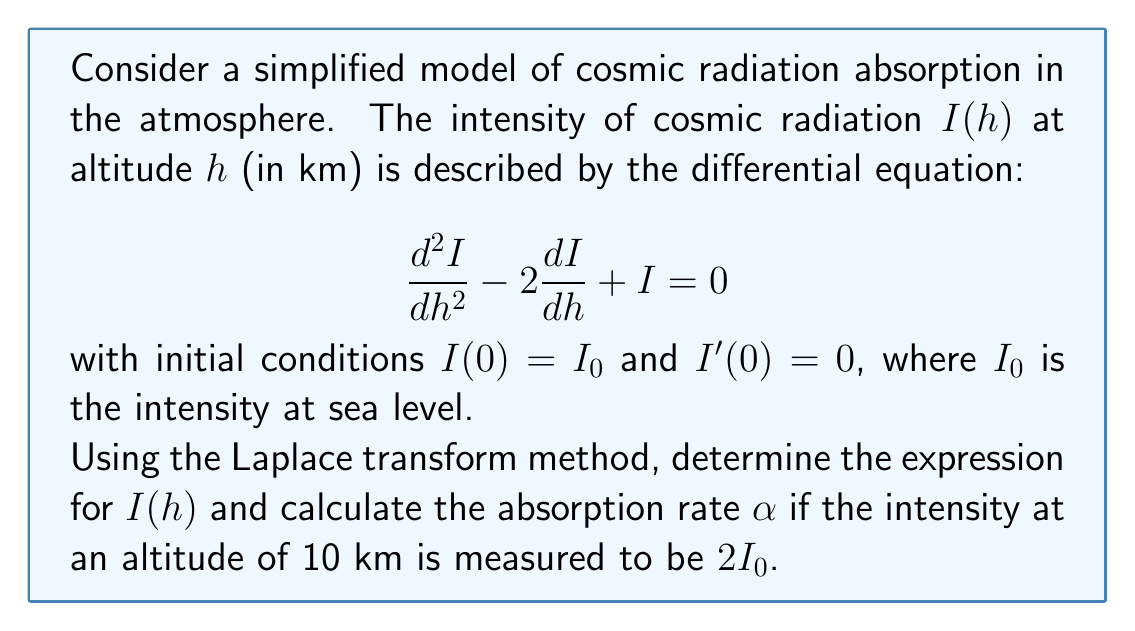Solve this math problem. Let's solve this problem step by step using the Laplace transform method:

1) First, let's take the Laplace transform of both sides of the differential equation:
   $$\mathcal{L}\{I''(h)\} - 2\mathcal{L}\{I'(h)\} + \mathcal{L}\{I(h)\} = 0$$

2) Using the properties of Laplace transforms:
   $$s^2\mathcal{L}\{I(h)\} - sI(0) - I'(0) - 2[s\mathcal{L}\{I(h)\} - I(0)] + \mathcal{L}\{I(h)\} = 0$$

3) Substituting the initial conditions and let $\mathcal{L}\{I(h)\} = Y(s)$:
   $$s^2Y(s) - sI_0 - 2sY(s) + 2I_0 + Y(s) = 0$$

4) Rearranging terms:
   $$(s^2 - 2s + 1)Y(s) = I_0(s - 2)$$

5) Solving for $Y(s)$:
   $$Y(s) = \frac{I_0(s-2)}{(s-1)^2} = I_0\left(\frac{1}{s-1} + \frac{1}{(s-1)^2}\right)$$

6) Taking the inverse Laplace transform:
   $$I(h) = I_0(1 + h)e^h$$

7) To find the absorption rate $\alpha$, we use the general form of exponential decay:
   $$I(h) = I_0e^{-\alpha h}$$

8) Comparing this with our solution:
   $$I_0(1 + h)e^h = I_0e^{-\alpha h}$$

9) At h = 10 km, we're given that $I(10) = 2I_0$:
   $$I_0(1 + 10)e^{10} = 2I_0 = I_0e^{-10\alpha}$$

10) Solving for $\alpha$:
    $$11e^{10} = e^{-10\alpha}$$
    $$\ln(11) + 10 = -10\alpha$$
    $$\alpha = -\frac{\ln(11) + 10}{10} \approx 0.0759$$
Answer: The intensity of cosmic radiation as a function of altitude is given by:

$$I(h) = I_0(1 + h)e^h$$

The absorption rate $\alpha$ is approximately 0.0759 km^(-1). 